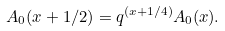Convert formula to latex. <formula><loc_0><loc_0><loc_500><loc_500>A _ { 0 } ( x + 1 / 2 ) = q ^ { ( x + 1 / 4 ) } A _ { 0 } ( x ) .</formula> 